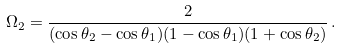<formula> <loc_0><loc_0><loc_500><loc_500>\Omega _ { 2 } = \frac { 2 } { ( \cos \theta _ { 2 } - \cos \theta _ { 1 } ) ( 1 - \cos \theta _ { 1 } ) ( 1 + \cos \theta _ { 2 } ) } \, .</formula> 